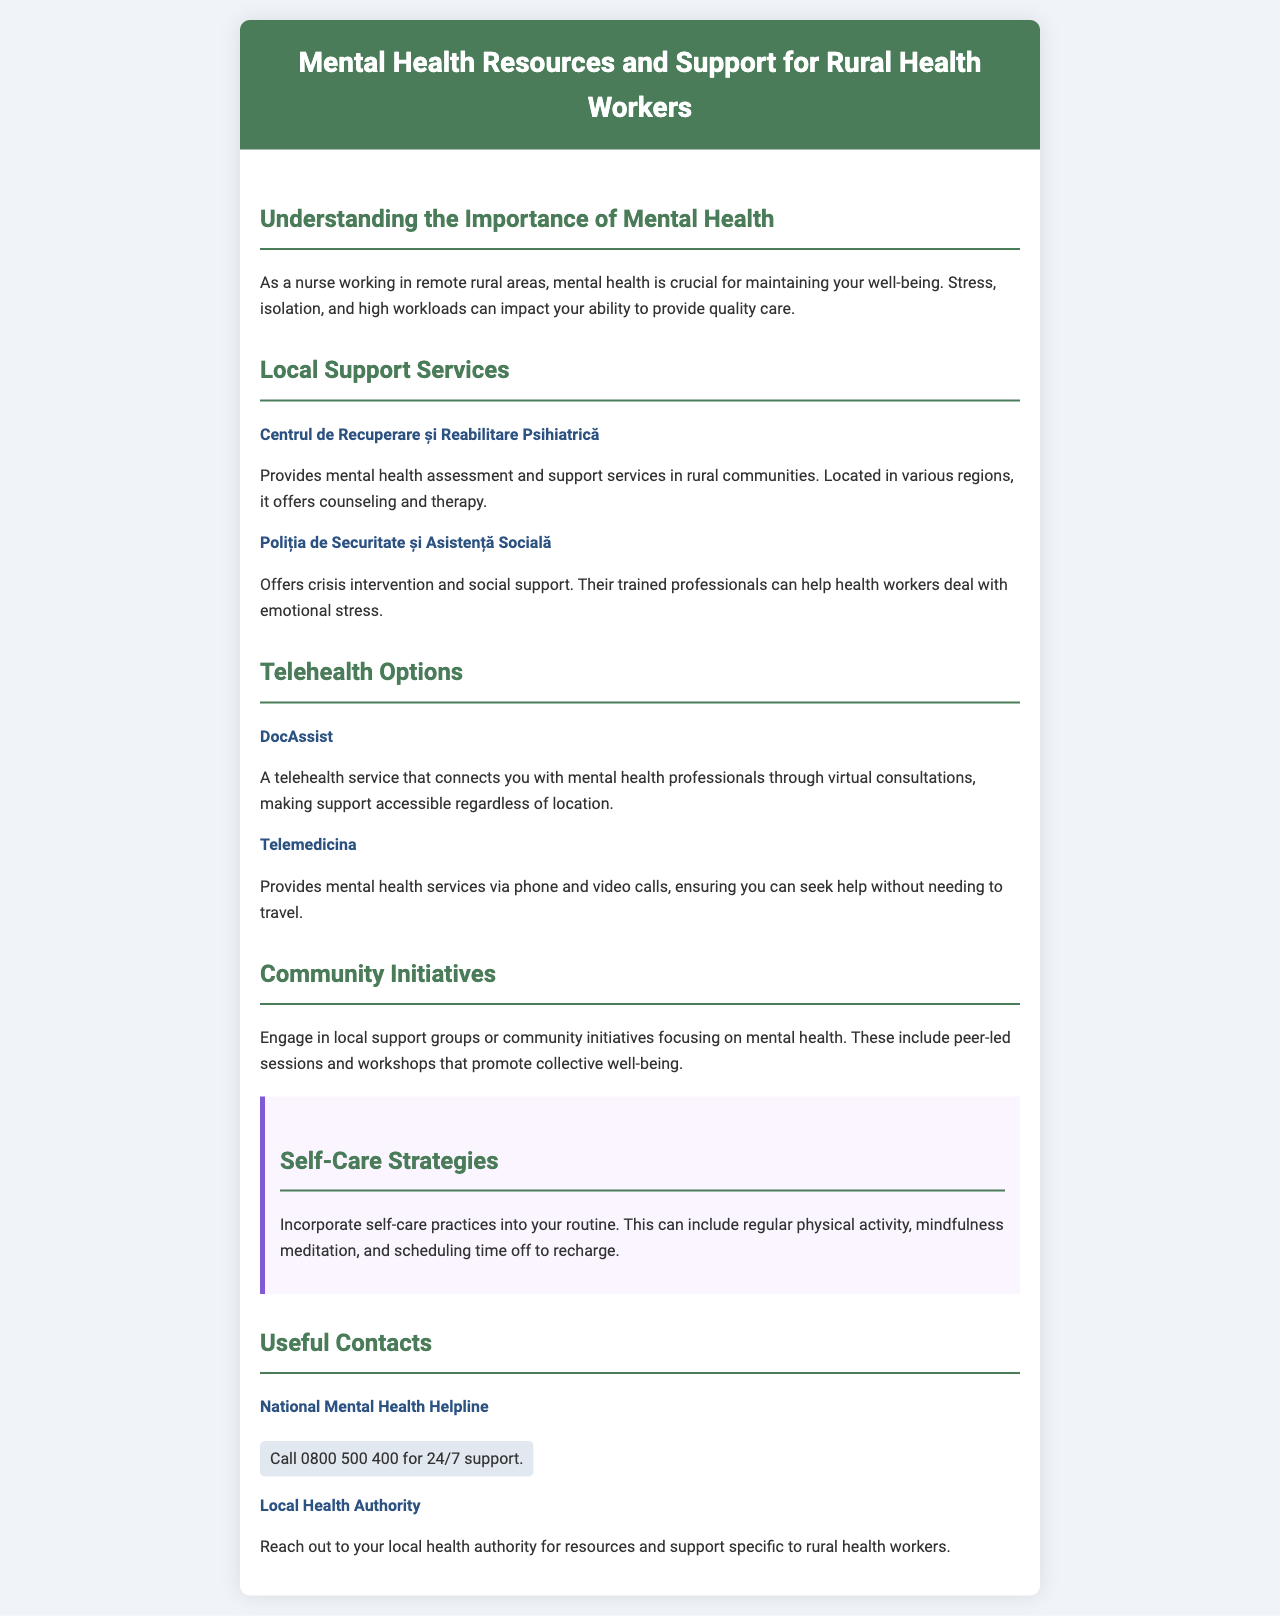What is the title of the brochure? The title of the brochure is displayed prominently at the top of the document.
Answer: Mental Health Resources and Support for Rural Health Workers What service does Centrul de Recuperare și Reabilitare Psihiatrică provide? This service offers mental health assessment and support services in rural communities.
Answer: Mental health assessment and support services What are the two telehealth options mentioned? The document lists specific telehealth services relevant to mental health.
Answer: DocAssist and Telemedicina What is one community initiative suggested in the brochure? The brochure mentions various ways to engage with the community for mental health support.
Answer: Local support groups What is the contact number for the National Mental Health Helpline? This number is provided for immediate assistance to those in need of support.
Answer: 0800 500 400 Why is mental health important for rural health workers? The document discusses key challenges faced by rural health workers that affect their mental health.
Answer: Stress, isolation, and high workloads What self-care strategy is suggested in the document? The brochure provides practical advice on how to maintain one's mental health.
Answer: Mindfulness meditation 